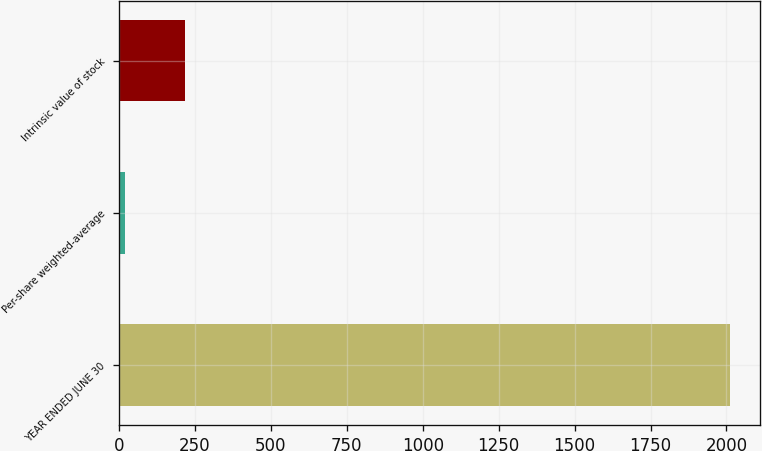Convert chart to OTSL. <chart><loc_0><loc_0><loc_500><loc_500><bar_chart><fcel>YEAR ENDED JUNE 30<fcel>Per-share weighted-average<fcel>Intrinsic value of stock<nl><fcel>2011<fcel>18.93<fcel>218.14<nl></chart> 